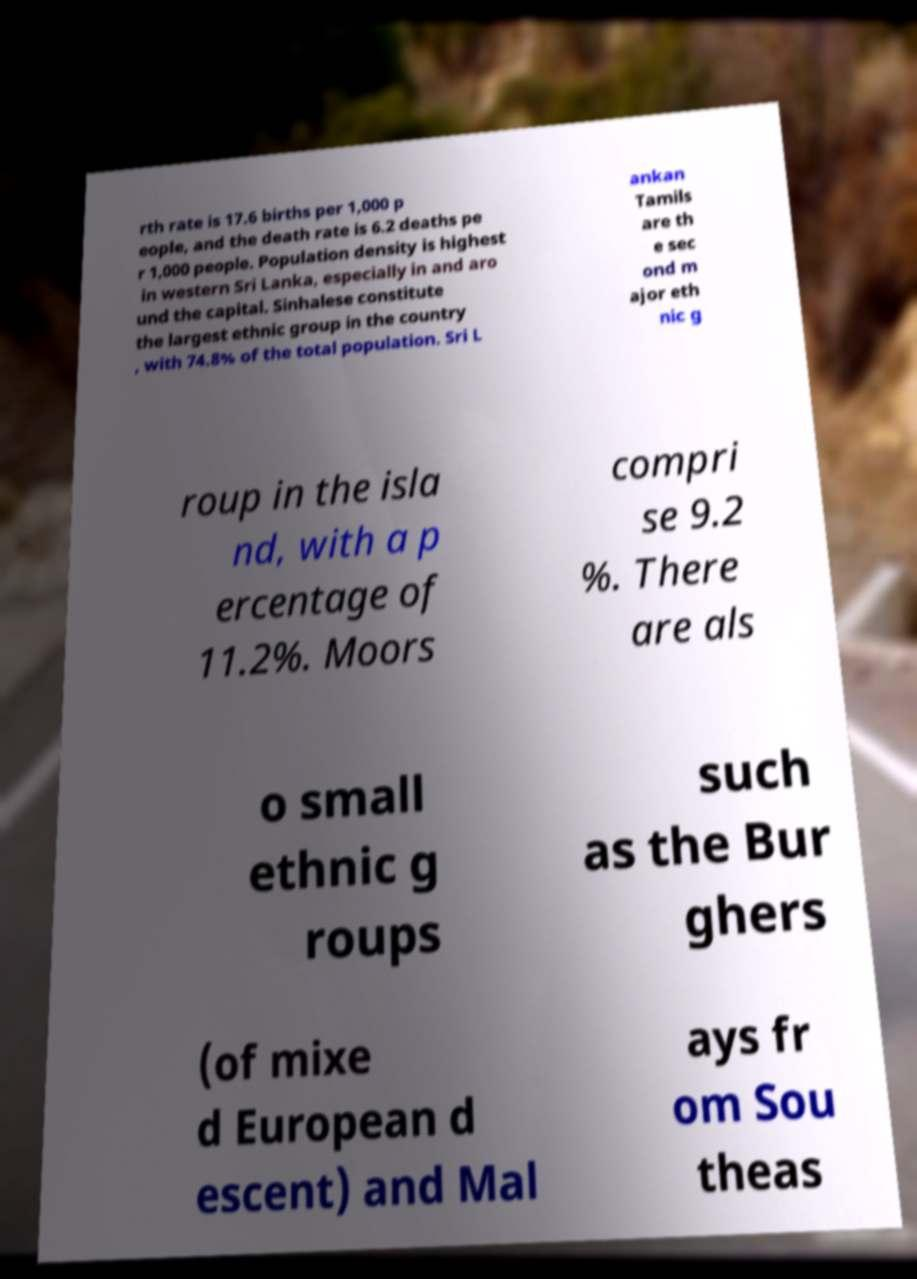Could you extract and type out the text from this image? rth rate is 17.6 births per 1,000 p eople, and the death rate is 6.2 deaths pe r 1,000 people. Population density is highest in western Sri Lanka, especially in and aro und the capital. Sinhalese constitute the largest ethnic group in the country , with 74.8% of the total population. Sri L ankan Tamils are th e sec ond m ajor eth nic g roup in the isla nd, with a p ercentage of 11.2%. Moors compri se 9.2 %. There are als o small ethnic g roups such as the Bur ghers (of mixe d European d escent) and Mal ays fr om Sou theas 